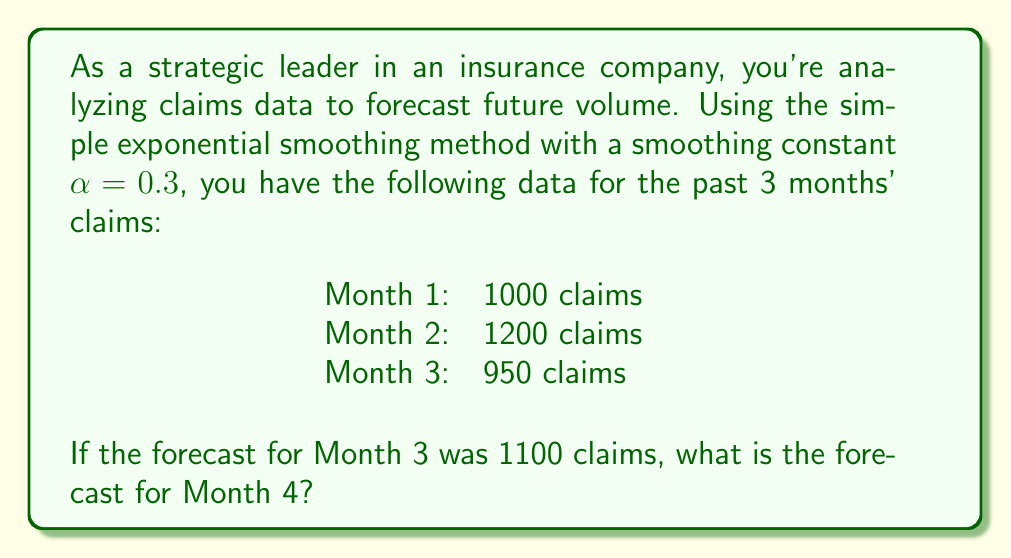Can you answer this question? To solve this problem, we'll use the simple exponential smoothing formula:

$$F_{t+1} = \alpha Y_t + (1-\alpha)F_t$$

Where:
$F_{t+1}$ is the forecast for the next period
$\alpha$ is the smoothing constant (0.3 in this case)
$Y_t$ is the actual value for the current period
$F_t$ is the forecast for the current period

We're given:
$\alpha = 0.3$
$Y_3 = 950$ (actual claims for Month 3)
$F_3 = 1100$ (forecast for Month 3)

Let's calculate the forecast for Month 4 ($F_4$):

$$\begin{align}
F_4 &= \alpha Y_3 + (1-\alpha)F_3 \\
&= 0.3 \times 950 + (1-0.3) \times 1100 \\
&= 285 + 0.7 \times 1100 \\
&= 285 + 770 \\
&= 1055
\end{align}$$

Therefore, the forecast for Month 4 is 1055 claims.

This method allows the strategic leader to provide a data-driven forecast to the claims manager, helping them allocate resources appropriately for the upcoming month.
Answer: 1055 claims 